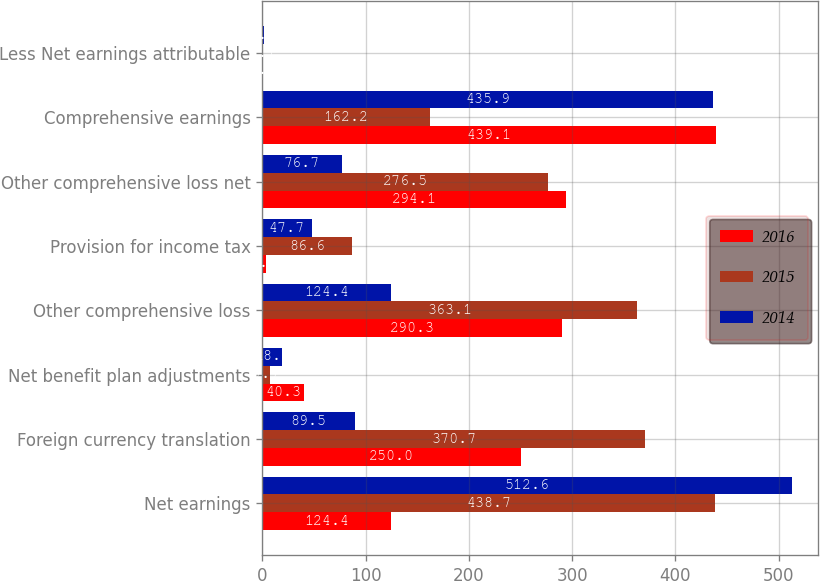<chart> <loc_0><loc_0><loc_500><loc_500><stacked_bar_chart><ecel><fcel>Net earnings<fcel>Foreign currency translation<fcel>Net benefit plan adjustments<fcel>Other comprehensive loss<fcel>Provision for income tax<fcel>Other comprehensive loss net<fcel>Comprehensive earnings<fcel>Less Net earnings attributable<nl><fcel>2016<fcel>124.4<fcel>250<fcel>40.3<fcel>290.3<fcel>3.8<fcel>294.1<fcel>439.1<fcel>1.1<nl><fcel>2015<fcel>438.7<fcel>370.7<fcel>7.7<fcel>363.1<fcel>86.6<fcel>276.5<fcel>162.2<fcel>1.1<nl><fcel>2014<fcel>512.6<fcel>89.5<fcel>18.6<fcel>124.4<fcel>47.7<fcel>76.7<fcel>435.9<fcel>1.4<nl></chart> 